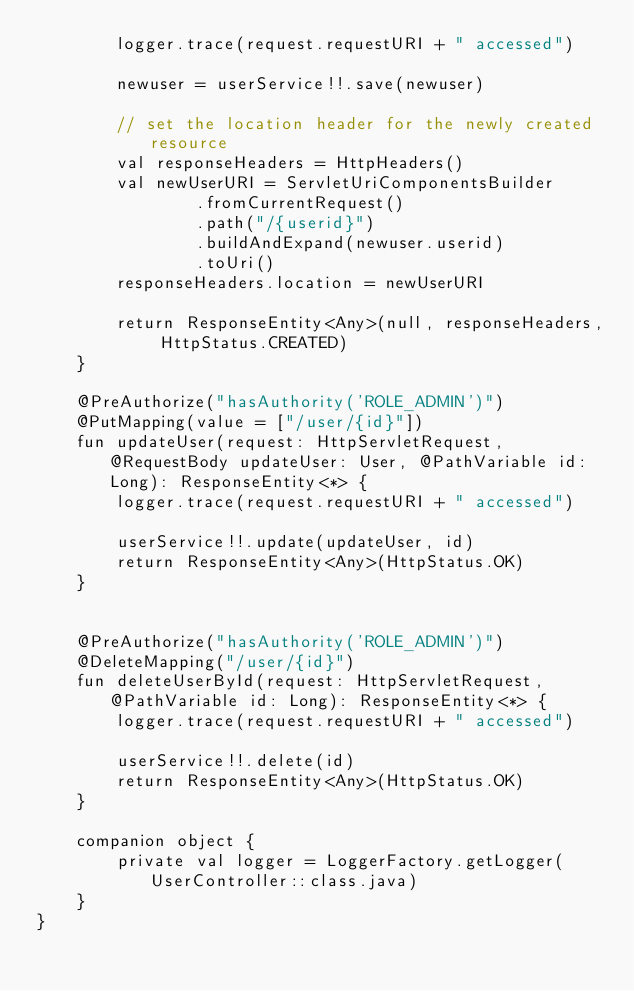Convert code to text. <code><loc_0><loc_0><loc_500><loc_500><_Kotlin_>        logger.trace(request.requestURI + " accessed")

        newuser = userService!!.save(newuser)

        // set the location header for the newly created resource
        val responseHeaders = HttpHeaders()
        val newUserURI = ServletUriComponentsBuilder
                .fromCurrentRequest()
                .path("/{userid}")
                .buildAndExpand(newuser.userid)
                .toUri()
        responseHeaders.location = newUserURI

        return ResponseEntity<Any>(null, responseHeaders, HttpStatus.CREATED)
    }

    @PreAuthorize("hasAuthority('ROLE_ADMIN')")
    @PutMapping(value = ["/user/{id}"])
    fun updateUser(request: HttpServletRequest, @RequestBody updateUser: User, @PathVariable id: Long): ResponseEntity<*> {
        logger.trace(request.requestURI + " accessed")

        userService!!.update(updateUser, id)
        return ResponseEntity<Any>(HttpStatus.OK)
    }


    @PreAuthorize("hasAuthority('ROLE_ADMIN')")
    @DeleteMapping("/user/{id}")
    fun deleteUserById(request: HttpServletRequest, @PathVariable id: Long): ResponseEntity<*> {
        logger.trace(request.requestURI + " accessed")

        userService!!.delete(id)
        return ResponseEntity<Any>(HttpStatus.OK)
    }

    companion object {
        private val logger = LoggerFactory.getLogger(UserController::class.java)
    }
}</code> 